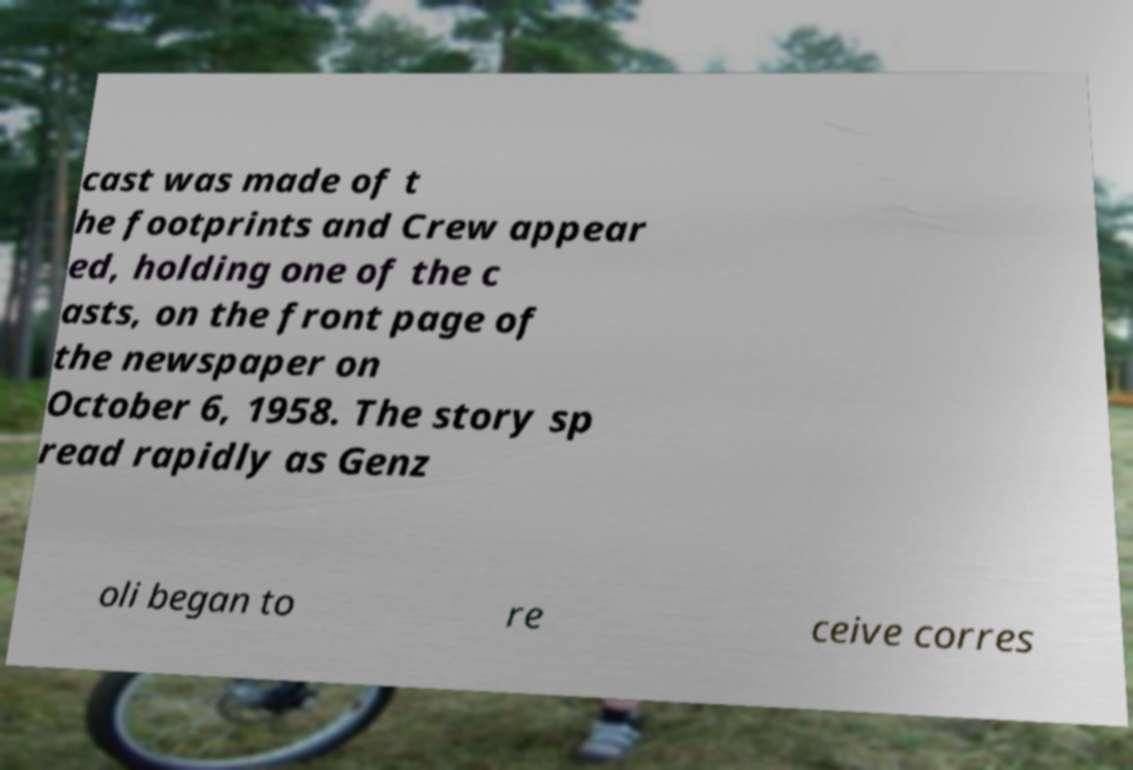Can you read and provide the text displayed in the image?This photo seems to have some interesting text. Can you extract and type it out for me? cast was made of t he footprints and Crew appear ed, holding one of the c asts, on the front page of the newspaper on October 6, 1958. The story sp read rapidly as Genz oli began to re ceive corres 